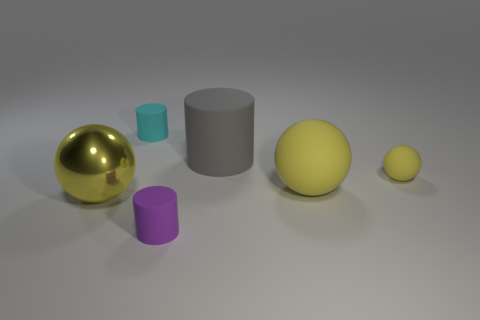There is a small object that is the same color as the large rubber sphere; what is it made of?
Your answer should be compact. Rubber. What material is the yellow ball that is the same size as the purple object?
Keep it short and to the point. Rubber. Are there any spheres that have the same color as the large shiny object?
Provide a succinct answer. Yes. What shape is the rubber object that is in front of the cyan matte cylinder and behind the small yellow ball?
Your response must be concise. Cylinder. What number of big spheres are made of the same material as the small yellow object?
Your answer should be compact. 1. Is the number of matte cylinders that are right of the tiny yellow rubber sphere less than the number of balls left of the cyan object?
Give a very brief answer. Yes. What material is the large yellow object in front of the big ball that is right of the tiny cylinder that is behind the tiny yellow matte thing made of?
Your response must be concise. Metal. What is the size of the rubber object that is behind the small purple rubber cylinder and to the left of the big gray cylinder?
Offer a very short reply. Small. What number of cubes are small purple matte things or cyan matte things?
Make the answer very short. 0. The metallic sphere that is the same size as the gray cylinder is what color?
Provide a succinct answer. Yellow. 